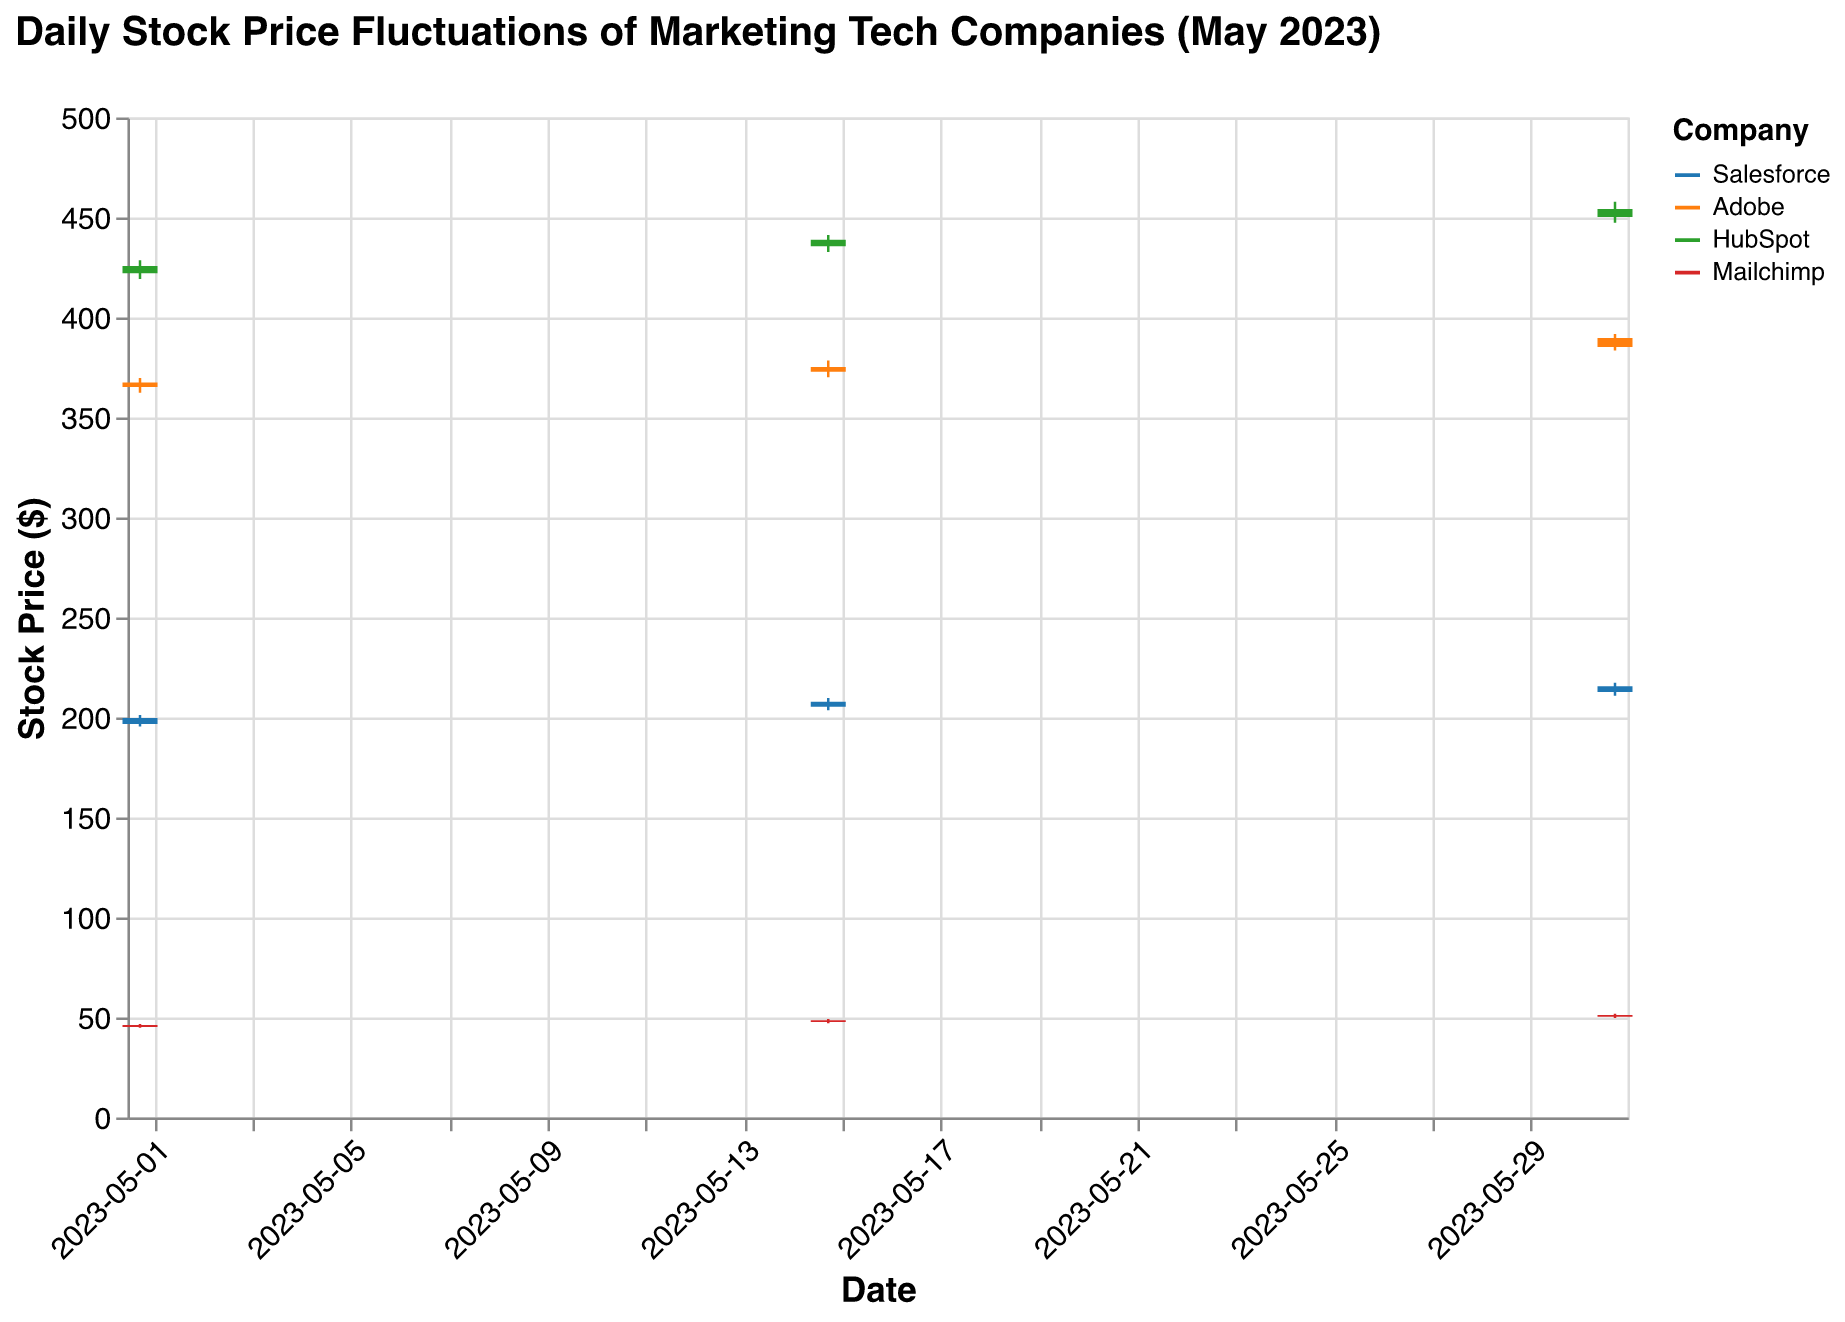What is the title of the OHLC chart? The title of the chart is written at the top and summarizes the main information presented. It says, "Daily Stock Price Fluctuations of Marketing Tech Companies (May 2023)"
Answer: Daily Stock Price Fluctuations of Marketing Tech Companies (May 2023) Which company has the highest stock price on May 31, 2023? By looking at the high points of the bars and the vertical lines (OHLC markers) on May 31, 2023, one can see that HubSpot's stock price reached the highest point at 457.90
Answer: HubSpot What is the difference between the highest and lowest stock prices for Adobe on May 31, 2023? Adobe's highest stock price on May 31, 2023, is 391.80, and the lowest is 383.50. The difference is calculated as 391.80 - 383.50 = 8.30
Answer: 8.30 What trend can be observed for Mailchimp's closing stock price throughout the month of May? The closing stock prices for Mailchimp on May 1, May 15, and May 31 are 46.20, 48.60, and 51.30 respectively. It can be observed that Mailchimp's closing stock price steadily increased throughout May
Answer: Steadily increased Which company had the smallest range (High - Low) in stock prices on May 1, 2023? On May 1, 2023, the ranges for Salesforce, Adobe, HubSpot, and Mailchimp are: 201.25 - 195.50 = 5.75, 369.80 - 362.40 = 7.40, 428.60 - 419.30 = 9.30, and 46.75 - 44.90 = 1.85 respectively. Mailchimp had the smallest range at 1.85
Answer: Mailchimp How did Salesforce's closing stock price change from May 1 to May 31, 2023? Salesforce's closing stock price on May 1, May 15, and May 31 are 199.75, 207.90, and 215.60 respectively. The stock price increased from 199.75 to 215.60 over the course of the month
Answer: Increased What is the average closing stock price for Adobe over the three days reported? Adobe's closing prices on May 1, May 15, and May 31 are 367.50, 375.30, and 389.70 respectively. The average is calculated as (367.50 + 375.30 + 389.70) / 3 = 377.50
Answer: 377.50 Compare the opening stock prices of HubSpot on May 1 and May 15, 2023. Which day had a higher opening price? HubSpot's opening stock price on May 1 is 422.10 and on May 15 is 435.60. May 15 had a higher opening price
Answer: May 15 Which company showed the most significant increase in closing stock prices from May 15 to May 31, 2023? Comparing the closing stock prices of May 15 and May 31 for each company: Salesforce (207.90 to 215.60: +7.70), Adobe (375.30 to 389.70: +14.40), HubSpot (438.90 to 454.30: +15.40), Mailchimp (48.60 to 51.30: +2.70). HubSpot showed the most significant increase
Answer: HubSpot 